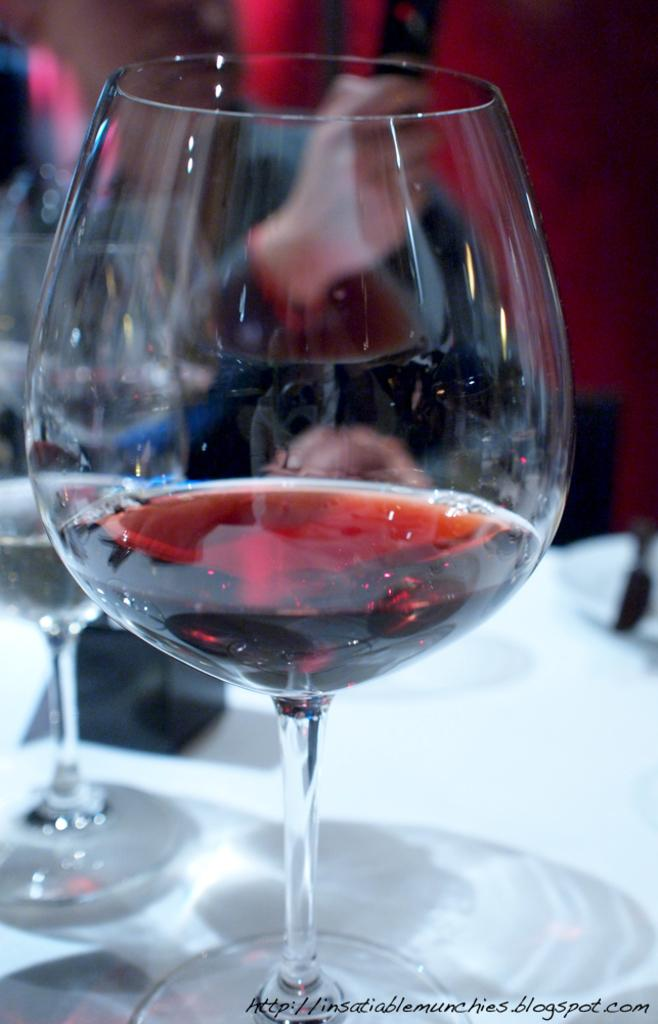What is located at the bottom of the image? There is a table at the bottom of the image. What can be seen on the table? There are glasses and other objects on the table. Can you describe the background of the image? The background of the image is blurred. What part of a person can be seen in the background of the image? A person's hand is visible in the background of the image. What type of apparatus is being used by the girls in the image? There are no girls or apparatus present in the image. 